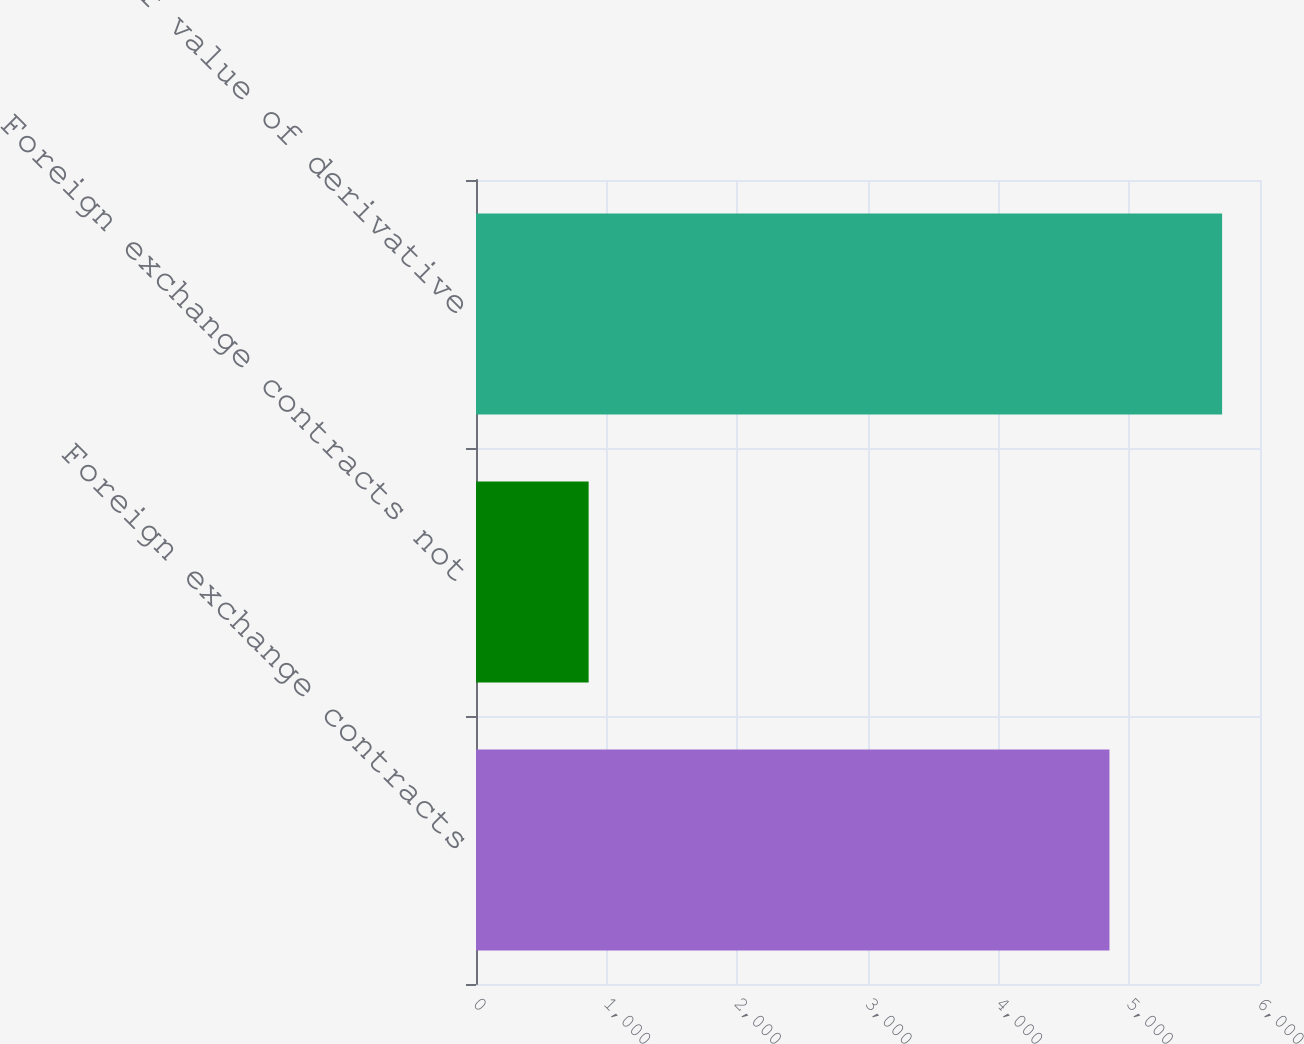Convert chart to OTSL. <chart><loc_0><loc_0><loc_500><loc_500><bar_chart><fcel>Foreign exchange contracts<fcel>Foreign exchange contracts not<fcel>Total fair value of derivative<nl><fcel>4848<fcel>862<fcel>5710<nl></chart> 